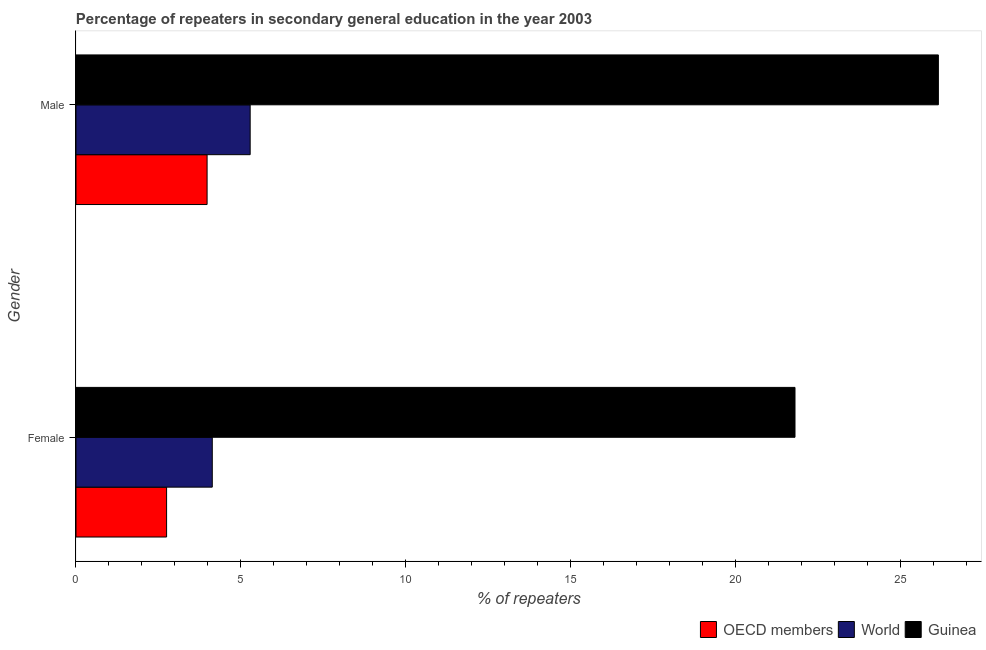How many groups of bars are there?
Your answer should be very brief. 2. How many bars are there on the 1st tick from the top?
Keep it short and to the point. 3. What is the label of the 1st group of bars from the top?
Offer a terse response. Male. What is the percentage of male repeaters in Guinea?
Offer a terse response. 26.15. Across all countries, what is the maximum percentage of male repeaters?
Provide a succinct answer. 26.15. Across all countries, what is the minimum percentage of male repeaters?
Ensure brevity in your answer.  3.97. In which country was the percentage of male repeaters maximum?
Keep it short and to the point. Guinea. In which country was the percentage of female repeaters minimum?
Your answer should be very brief. OECD members. What is the total percentage of female repeaters in the graph?
Your answer should be very brief. 28.68. What is the difference between the percentage of male repeaters in World and that in OECD members?
Your response must be concise. 1.31. What is the difference between the percentage of male repeaters in World and the percentage of female repeaters in OECD members?
Keep it short and to the point. 2.53. What is the average percentage of female repeaters per country?
Your answer should be very brief. 9.56. What is the difference between the percentage of female repeaters and percentage of male repeaters in World?
Give a very brief answer. -1.15. In how many countries, is the percentage of female repeaters greater than 25 %?
Your response must be concise. 0. What is the ratio of the percentage of male repeaters in World to that in OECD members?
Offer a terse response. 1.33. What does the 1st bar from the top in Male represents?
Your answer should be very brief. Guinea. What does the 3rd bar from the bottom in Female represents?
Your answer should be compact. Guinea. What is the difference between two consecutive major ticks on the X-axis?
Offer a terse response. 5. Are the values on the major ticks of X-axis written in scientific E-notation?
Offer a very short reply. No. Does the graph contain any zero values?
Your answer should be compact. No. Does the graph contain grids?
Ensure brevity in your answer.  No. Where does the legend appear in the graph?
Offer a terse response. Bottom right. How many legend labels are there?
Give a very brief answer. 3. How are the legend labels stacked?
Make the answer very short. Horizontal. What is the title of the graph?
Your answer should be compact. Percentage of repeaters in secondary general education in the year 2003. Does "Sri Lanka" appear as one of the legend labels in the graph?
Your answer should be compact. No. What is the label or title of the X-axis?
Keep it short and to the point. % of repeaters. What is the label or title of the Y-axis?
Ensure brevity in your answer.  Gender. What is the % of repeaters in OECD members in Female?
Your response must be concise. 2.75. What is the % of repeaters in World in Female?
Provide a succinct answer. 4.13. What is the % of repeaters of Guinea in Female?
Make the answer very short. 21.8. What is the % of repeaters in OECD members in Male?
Provide a succinct answer. 3.97. What is the % of repeaters of World in Male?
Offer a terse response. 5.28. What is the % of repeaters in Guinea in Male?
Ensure brevity in your answer.  26.15. Across all Gender, what is the maximum % of repeaters of OECD members?
Keep it short and to the point. 3.97. Across all Gender, what is the maximum % of repeaters in World?
Your response must be concise. 5.28. Across all Gender, what is the maximum % of repeaters of Guinea?
Offer a very short reply. 26.15. Across all Gender, what is the minimum % of repeaters of OECD members?
Your answer should be compact. 2.75. Across all Gender, what is the minimum % of repeaters in World?
Offer a terse response. 4.13. Across all Gender, what is the minimum % of repeaters in Guinea?
Your response must be concise. 21.8. What is the total % of repeaters in OECD members in the graph?
Provide a succinct answer. 6.72. What is the total % of repeaters in World in the graph?
Your response must be concise. 9.41. What is the total % of repeaters in Guinea in the graph?
Provide a succinct answer. 47.95. What is the difference between the % of repeaters in OECD members in Female and that in Male?
Your answer should be very brief. -1.23. What is the difference between the % of repeaters of World in Female and that in Male?
Make the answer very short. -1.15. What is the difference between the % of repeaters of Guinea in Female and that in Male?
Ensure brevity in your answer.  -4.35. What is the difference between the % of repeaters of OECD members in Female and the % of repeaters of World in Male?
Your response must be concise. -2.53. What is the difference between the % of repeaters in OECD members in Female and the % of repeaters in Guinea in Male?
Give a very brief answer. -23.4. What is the difference between the % of repeaters of World in Female and the % of repeaters of Guinea in Male?
Your answer should be compact. -22.02. What is the average % of repeaters of OECD members per Gender?
Offer a very short reply. 3.36. What is the average % of repeaters of World per Gender?
Ensure brevity in your answer.  4.71. What is the average % of repeaters in Guinea per Gender?
Your answer should be compact. 23.97. What is the difference between the % of repeaters of OECD members and % of repeaters of World in Female?
Keep it short and to the point. -1.39. What is the difference between the % of repeaters in OECD members and % of repeaters in Guinea in Female?
Provide a short and direct response. -19.05. What is the difference between the % of repeaters of World and % of repeaters of Guinea in Female?
Keep it short and to the point. -17.67. What is the difference between the % of repeaters of OECD members and % of repeaters of World in Male?
Provide a succinct answer. -1.31. What is the difference between the % of repeaters in OECD members and % of repeaters in Guinea in Male?
Ensure brevity in your answer.  -22.17. What is the difference between the % of repeaters in World and % of repeaters in Guinea in Male?
Make the answer very short. -20.87. What is the ratio of the % of repeaters of OECD members in Female to that in Male?
Offer a terse response. 0.69. What is the ratio of the % of repeaters of World in Female to that in Male?
Give a very brief answer. 0.78. What is the ratio of the % of repeaters of Guinea in Female to that in Male?
Offer a terse response. 0.83. What is the difference between the highest and the second highest % of repeaters in OECD members?
Make the answer very short. 1.23. What is the difference between the highest and the second highest % of repeaters of World?
Give a very brief answer. 1.15. What is the difference between the highest and the second highest % of repeaters of Guinea?
Your answer should be compact. 4.35. What is the difference between the highest and the lowest % of repeaters of OECD members?
Keep it short and to the point. 1.23. What is the difference between the highest and the lowest % of repeaters of World?
Ensure brevity in your answer.  1.15. What is the difference between the highest and the lowest % of repeaters of Guinea?
Your answer should be compact. 4.35. 